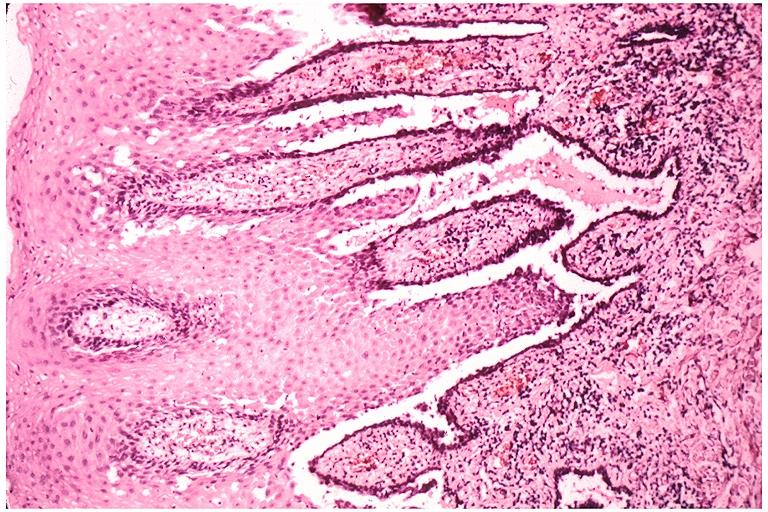what is present?
Answer the question using a single word or phrase. Oral 